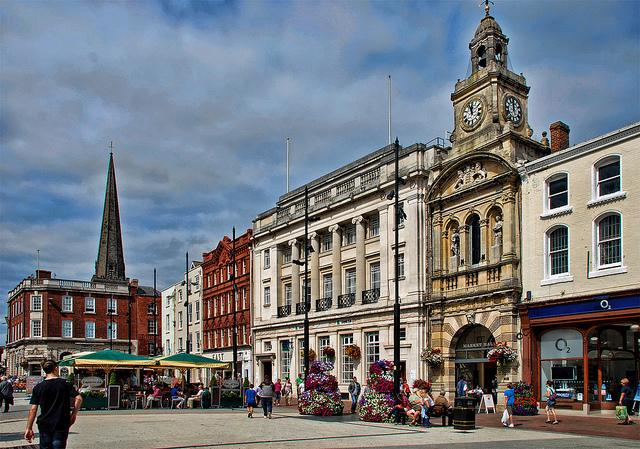How many clock faces can be seen on the clock tower?

Choices:
A) two
B) four
C) one
D) three two 